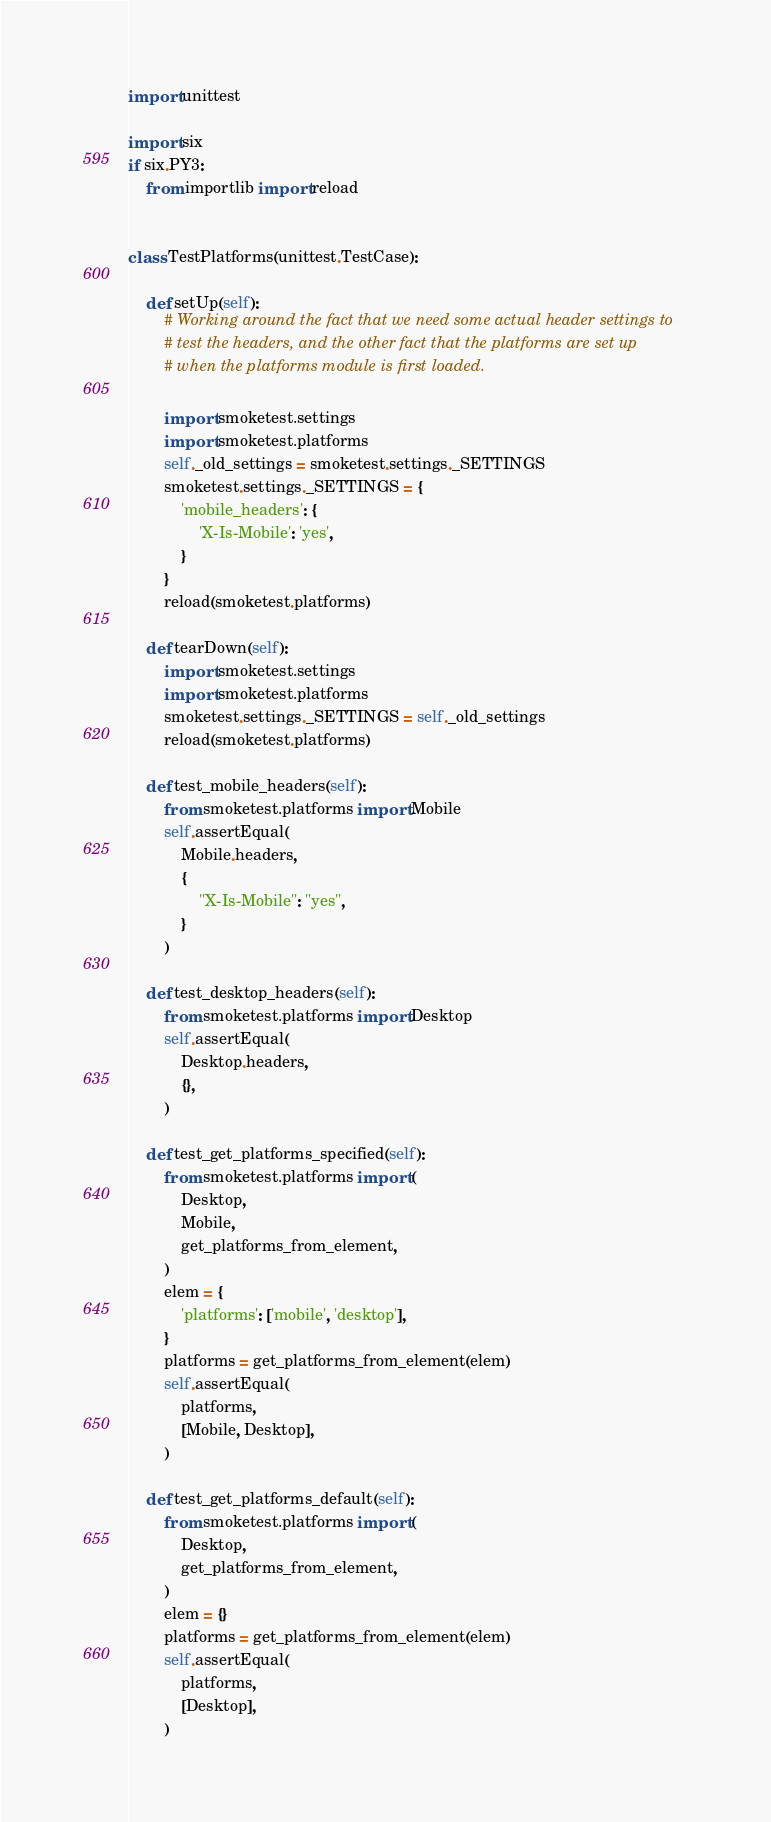Convert code to text. <code><loc_0><loc_0><loc_500><loc_500><_Python_>import unittest

import six
if six.PY3:
    from importlib import reload


class TestPlatforms(unittest.TestCase):

    def setUp(self):
        # Working around the fact that we need some actual header settings to
        # test the headers, and the other fact that the platforms are set up
        # when the platforms module is first loaded.

        import smoketest.settings
        import smoketest.platforms
        self._old_settings = smoketest.settings._SETTINGS
        smoketest.settings._SETTINGS = {
            'mobile_headers': {
                'X-Is-Mobile': 'yes',
            }
        }
        reload(smoketest.platforms)

    def tearDown(self):
        import smoketest.settings
        import smoketest.platforms
        smoketest.settings._SETTINGS = self._old_settings
        reload(smoketest.platforms)

    def test_mobile_headers(self):
        from smoketest.platforms import Mobile
        self.assertEqual(
            Mobile.headers,
            {
                "X-Is-Mobile": "yes",
            }
        )

    def test_desktop_headers(self):
        from smoketest.platforms import Desktop
        self.assertEqual(
            Desktop.headers,
            {},
        )

    def test_get_platforms_specified(self):
        from smoketest.platforms import (
            Desktop,
            Mobile,
            get_platforms_from_element,
        )
        elem = {
            'platforms': ['mobile', 'desktop'],
        }
        platforms = get_platforms_from_element(elem)
        self.assertEqual(
            platforms,
            [Mobile, Desktop],
        )

    def test_get_platforms_default(self):
        from smoketest.platforms import (
            Desktop,
            get_platforms_from_element,
        )
        elem = {}
        platforms = get_platforms_from_element(elem)
        self.assertEqual(
            platforms,
            [Desktop],
        )
</code> 